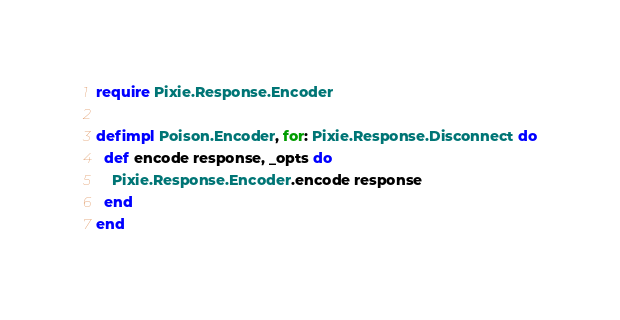Convert code to text. <code><loc_0><loc_0><loc_500><loc_500><_Elixir_>require Pixie.Response.Encoder

defimpl Poison.Encoder, for: Pixie.Response.Disconnect do
  def encode response, _opts do
    Pixie.Response.Encoder.encode response
  end
end
</code> 